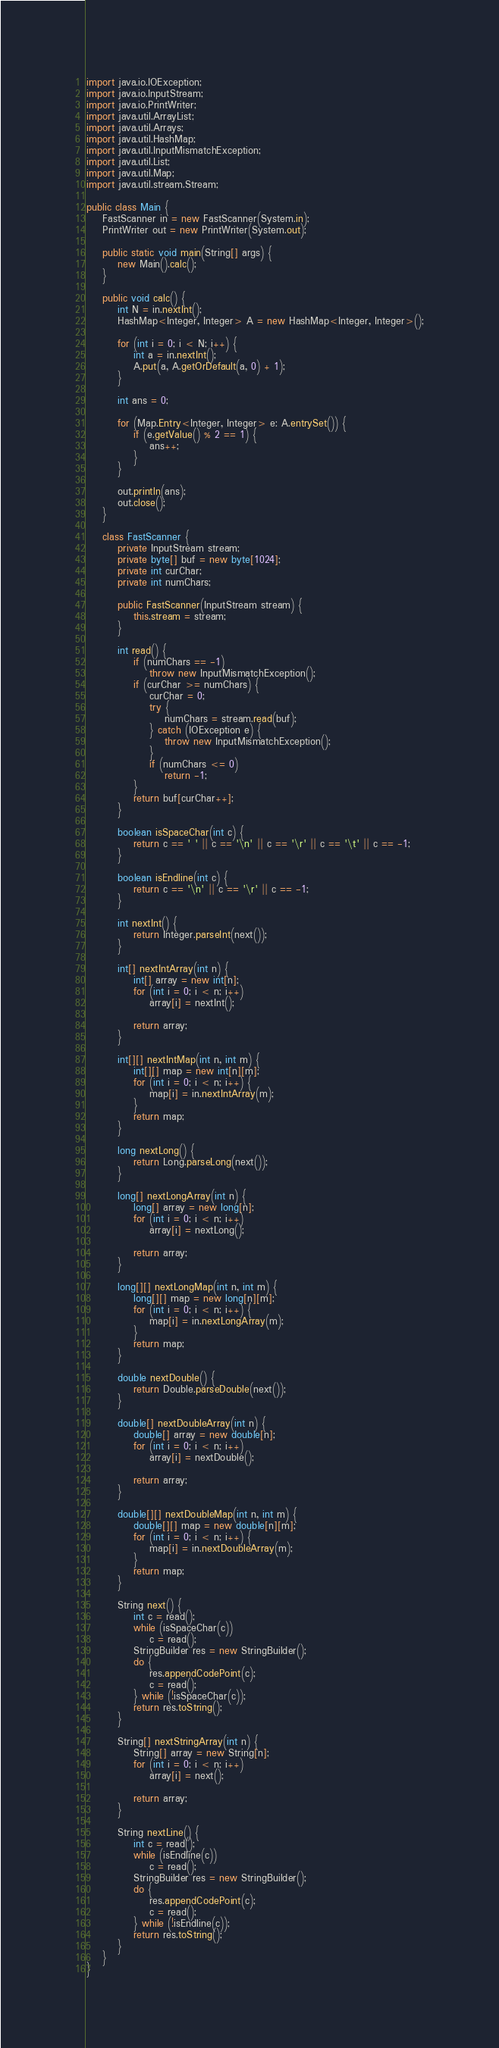Convert code to text. <code><loc_0><loc_0><loc_500><loc_500><_Java_>
import java.io.IOException;
import java.io.InputStream;
import java.io.PrintWriter;
import java.util.ArrayList;
import java.util.Arrays;
import java.util.HashMap;
import java.util.InputMismatchException;
import java.util.List;
import java.util.Map;
import java.util.stream.Stream;

public class Main {
    FastScanner in = new FastScanner(System.in);
    PrintWriter out = new PrintWriter(System.out);

    public static void main(String[] args) {
        new Main().calc();
    }
    
    public void calc() {
        int N = in.nextInt();
        HashMap<Integer, Integer> A = new HashMap<Integer, Integer>();

        for (int i = 0; i < N; i++) {
            int a = in.nextInt();
            A.put(a, A.getOrDefault(a, 0) + 1);
        }
        
        int ans = 0;
        
        for (Map.Entry<Integer, Integer> e: A.entrySet()) {
            if (e.getValue() % 2 == 1) {
                ans++;
            }
        }
        
        out.println(ans);
        out.close();
    }
    
    class FastScanner {
        private InputStream stream;
        private byte[] buf = new byte[1024];
        private int curChar;
        private int numChars;

        public FastScanner(InputStream stream) {
            this.stream = stream;
        }

        int read() {
            if (numChars == -1)
                throw new InputMismatchException();
            if (curChar >= numChars) {
                curChar = 0;
                try {
                    numChars = stream.read(buf);
                } catch (IOException e) {
                    throw new InputMismatchException();
                }
                if (numChars <= 0)
                    return -1;
            }
            return buf[curChar++];
        }

        boolean isSpaceChar(int c) {
            return c == ' ' || c == '\n' || c == '\r' || c == '\t' || c == -1;
        }

        boolean isEndline(int c) {
            return c == '\n' || c == '\r' || c == -1;
        }

        int nextInt() {
            return Integer.parseInt(next());
        }

        int[] nextIntArray(int n) {
            int[] array = new int[n];
            for (int i = 0; i < n; i++)
                array[i] = nextInt();

            return array;
        }

        int[][] nextIntMap(int n, int m) {
            int[][] map = new int[n][m];
            for (int i = 0; i < n; i++) {
                map[i] = in.nextIntArray(m);
            }
            return map;
        }

        long nextLong() {
            return Long.parseLong(next());
        }

        long[] nextLongArray(int n) {
            long[] array = new long[n];
            for (int i = 0; i < n; i++)
                array[i] = nextLong();

            return array;
        }

        long[][] nextLongMap(int n, int m) {
            long[][] map = new long[n][m];
            for (int i = 0; i < n; i++) {
                map[i] = in.nextLongArray(m);
            }
            return map;
        }

        double nextDouble() {
            return Double.parseDouble(next());
        }

        double[] nextDoubleArray(int n) {
            double[] array = new double[n];
            for (int i = 0; i < n; i++)
                array[i] = nextDouble();

            return array;
        }

        double[][] nextDoubleMap(int n, int m) {
            double[][] map = new double[n][m];
            for (int i = 0; i < n; i++) {
                map[i] = in.nextDoubleArray(m);
            }
            return map;
        }

        String next() {
            int c = read();
            while (isSpaceChar(c))
                c = read();
            StringBuilder res = new StringBuilder();
            do {
                res.appendCodePoint(c);
                c = read();
            } while (!isSpaceChar(c));
            return res.toString();
        }

        String[] nextStringArray(int n) {
            String[] array = new String[n];
            for (int i = 0; i < n; i++)
                array[i] = next();

            return array;
        }

        String nextLine() {
            int c = read();
            while (isEndline(c))
                c = read();
            StringBuilder res = new StringBuilder();
            do {
                res.appendCodePoint(c);
                c = read();
            } while (!isEndline(c));
            return res.toString();
        }
    }
}
</code> 